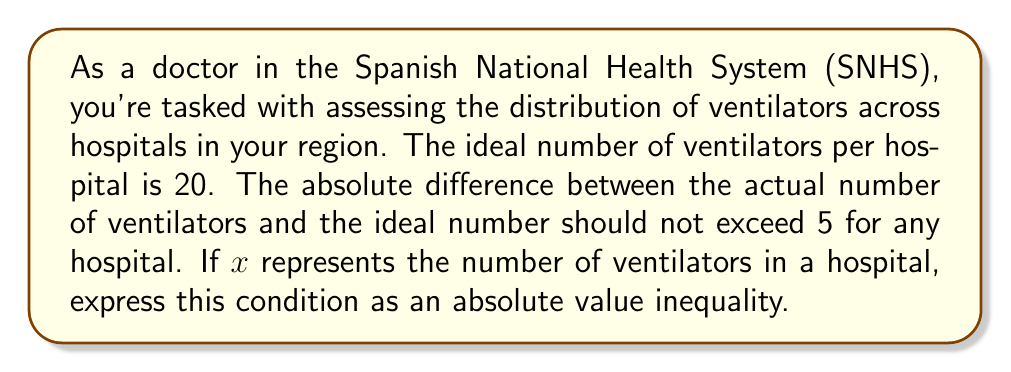Help me with this question. To solve this problem, we need to express the given information as an absolute value inequality:

1) The ideal number of ventilators is 20.
2) The difference between the actual number ($x$) and the ideal number (20) should not exceed 5.

We can express this as:
$$|x - 20| \leq 5$$

To solve this inequality:

1) First, we can rewrite the absolute value inequality as a compound inequality:
   $$-5 \leq x - 20 \leq 5$$

2) Now, we can solve both sides of the inequality by adding 20 to each part:
   $$-5 + 20 \leq x - 20 + 20 \leq 5 + 20$$
   $$15 \leq x \leq 25$$

This means that the number of ventilators in each hospital should be between 15 and 25, inclusive.

In the context of the SNHS, this inequality helps ensure a fair distribution of critical medical equipment across hospitals, addressing potential shortages or excesses that could impact patient care.
Answer: $$|x - 20| \leq 5$$
or
$$15 \leq x \leq 25$$
where $x$ is the number of ventilators in a hospital. 